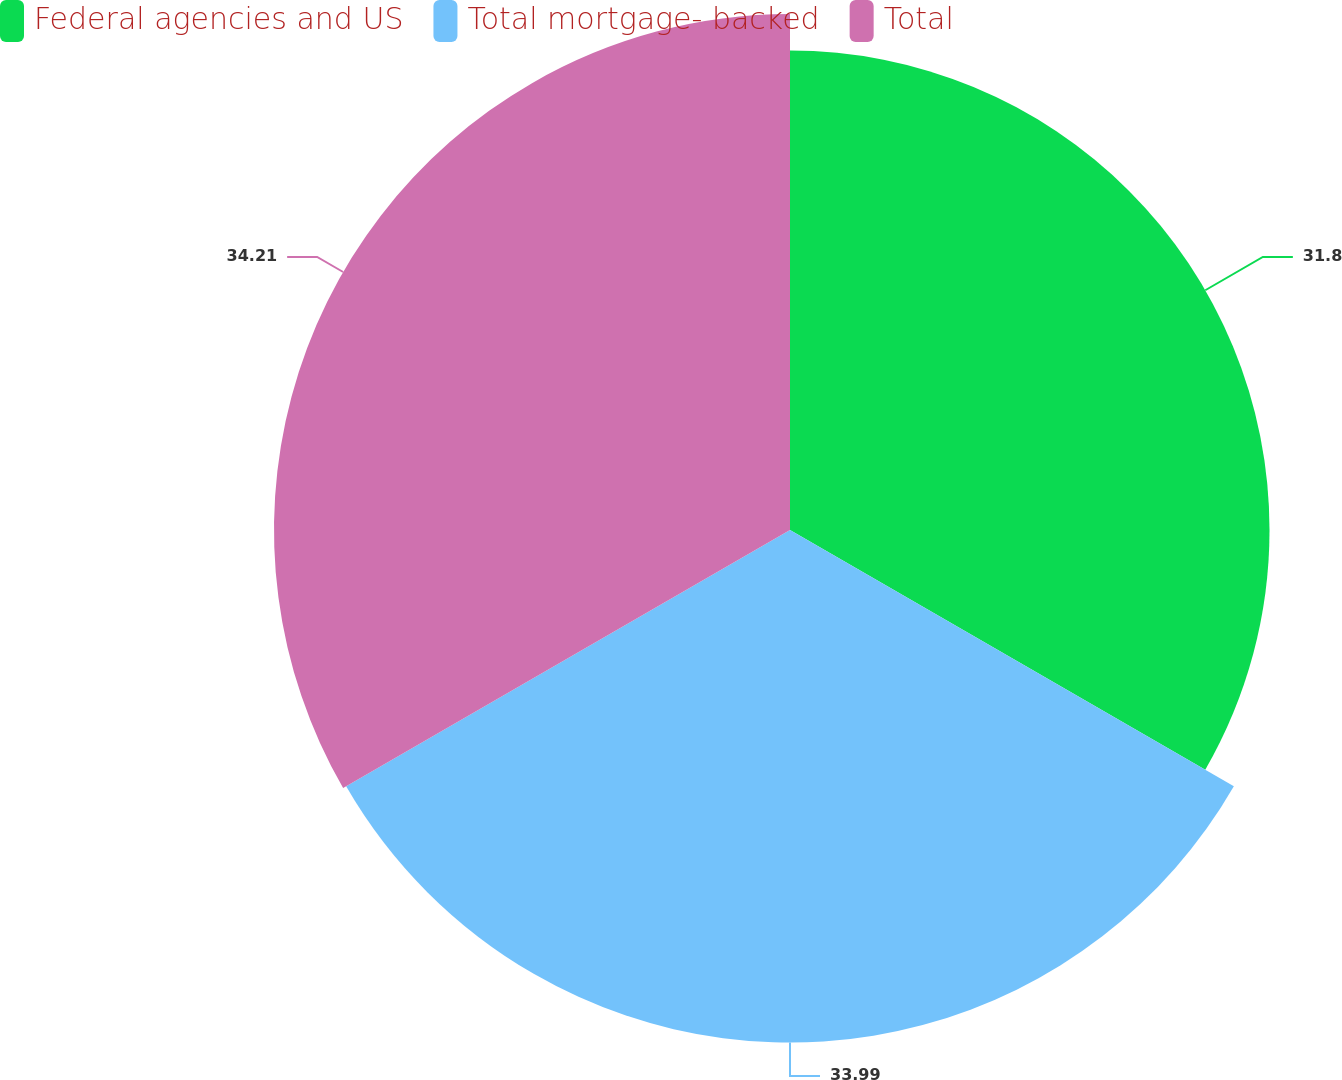Convert chart to OTSL. <chart><loc_0><loc_0><loc_500><loc_500><pie_chart><fcel>Federal agencies and US<fcel>Total mortgage- backed<fcel>Total<nl><fcel>31.8%<fcel>33.99%<fcel>34.22%<nl></chart> 